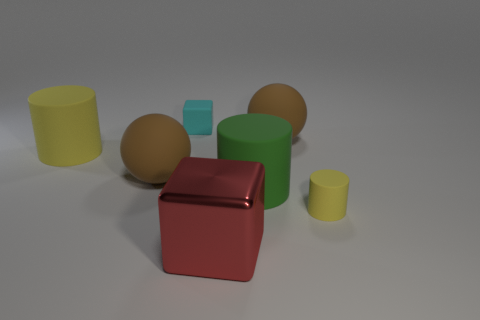Add 2 large cylinders. How many objects exist? 9 Subtract all balls. How many objects are left? 5 Subtract 2 yellow cylinders. How many objects are left? 5 Subtract all big yellow matte things. Subtract all rubber blocks. How many objects are left? 5 Add 6 green rubber cylinders. How many green rubber cylinders are left? 7 Add 2 large cylinders. How many large cylinders exist? 4 